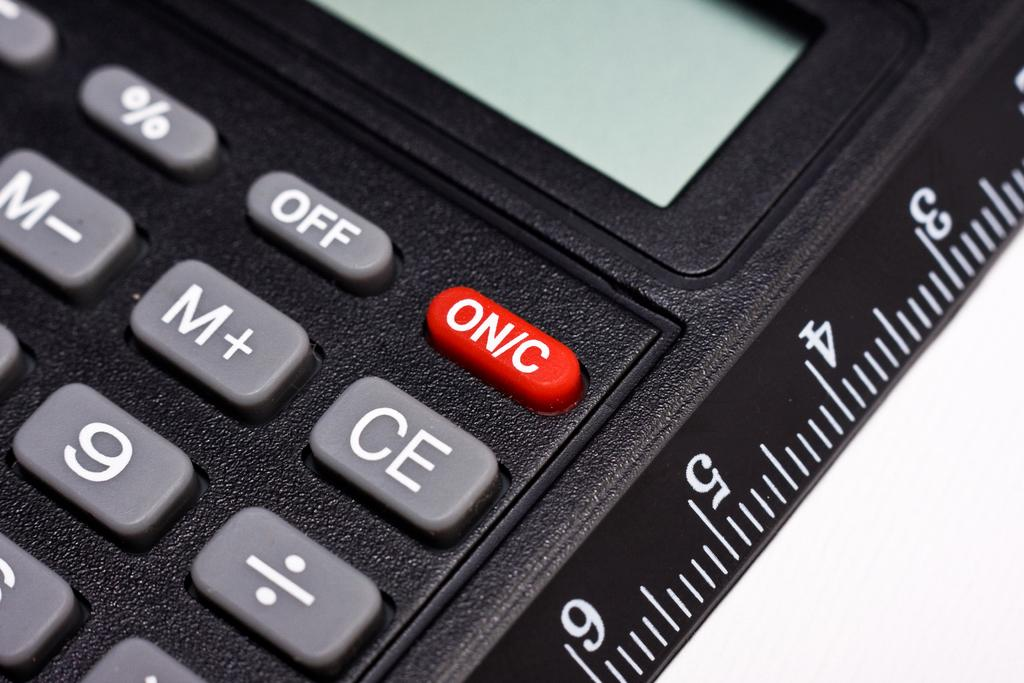<image>
Relay a brief, clear account of the picture shown. black calculator attached with a ruler the on button is red 